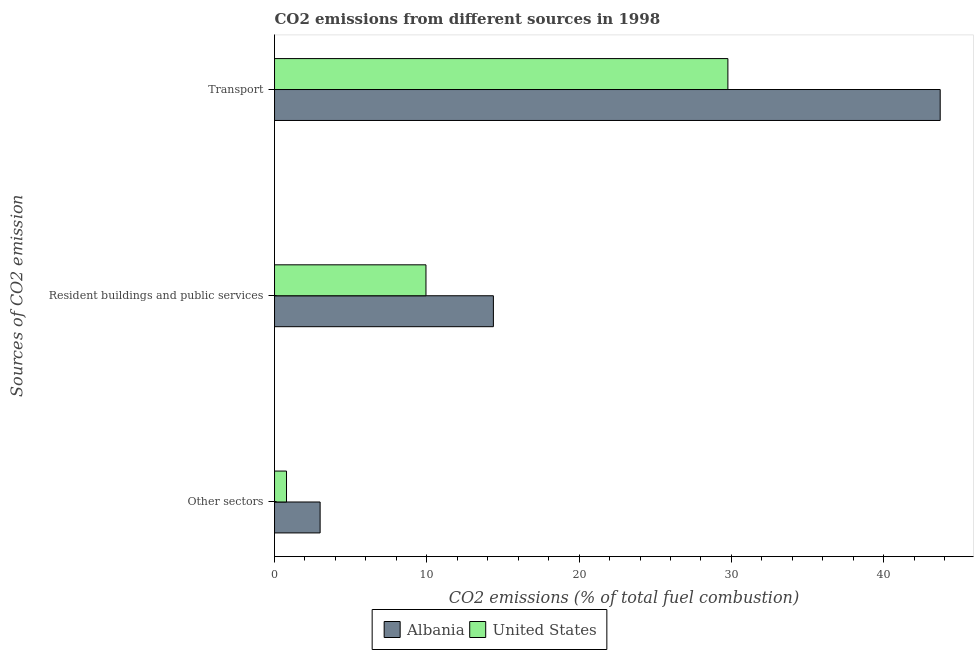How many different coloured bars are there?
Make the answer very short. 2. How many groups of bars are there?
Your response must be concise. 3. Are the number of bars per tick equal to the number of legend labels?
Offer a very short reply. Yes. Are the number of bars on each tick of the Y-axis equal?
Your answer should be compact. Yes. How many bars are there on the 1st tick from the bottom?
Make the answer very short. 2. What is the label of the 2nd group of bars from the top?
Provide a short and direct response. Resident buildings and public services. What is the percentage of co2 emissions from other sectors in Albania?
Provide a succinct answer. 2.99. Across all countries, what is the maximum percentage of co2 emissions from other sectors?
Ensure brevity in your answer.  2.99. Across all countries, what is the minimum percentage of co2 emissions from transport?
Offer a very short reply. 29.77. In which country was the percentage of co2 emissions from other sectors maximum?
Keep it short and to the point. Albania. What is the total percentage of co2 emissions from other sectors in the graph?
Give a very brief answer. 3.78. What is the difference between the percentage of co2 emissions from resident buildings and public services in United States and that in Albania?
Make the answer very short. -4.43. What is the difference between the percentage of co2 emissions from other sectors in United States and the percentage of co2 emissions from transport in Albania?
Your answer should be very brief. -42.93. What is the average percentage of co2 emissions from transport per country?
Your answer should be very brief. 36.74. What is the difference between the percentage of co2 emissions from resident buildings and public services and percentage of co2 emissions from other sectors in United States?
Your answer should be very brief. 9.16. What is the ratio of the percentage of co2 emissions from other sectors in United States to that in Albania?
Offer a very short reply. 0.26. Is the percentage of co2 emissions from other sectors in Albania less than that in United States?
Offer a terse response. No. What is the difference between the highest and the second highest percentage of co2 emissions from resident buildings and public services?
Offer a terse response. 4.43. What is the difference between the highest and the lowest percentage of co2 emissions from resident buildings and public services?
Provide a succinct answer. 4.43. In how many countries, is the percentage of co2 emissions from other sectors greater than the average percentage of co2 emissions from other sectors taken over all countries?
Your response must be concise. 1. Is it the case that in every country, the sum of the percentage of co2 emissions from other sectors and percentage of co2 emissions from resident buildings and public services is greater than the percentage of co2 emissions from transport?
Offer a very short reply. No. How many bars are there?
Keep it short and to the point. 6. How many countries are there in the graph?
Your answer should be compact. 2. What is the difference between two consecutive major ticks on the X-axis?
Ensure brevity in your answer.  10. Are the values on the major ticks of X-axis written in scientific E-notation?
Offer a very short reply. No. Does the graph contain grids?
Ensure brevity in your answer.  No. Where does the legend appear in the graph?
Offer a terse response. Bottom center. How many legend labels are there?
Offer a terse response. 2. How are the legend labels stacked?
Your answer should be compact. Horizontal. What is the title of the graph?
Your answer should be compact. CO2 emissions from different sources in 1998. What is the label or title of the X-axis?
Keep it short and to the point. CO2 emissions (% of total fuel combustion). What is the label or title of the Y-axis?
Keep it short and to the point. Sources of CO2 emission. What is the CO2 emissions (% of total fuel combustion) in Albania in Other sectors?
Make the answer very short. 2.99. What is the CO2 emissions (% of total fuel combustion) of United States in Other sectors?
Your response must be concise. 0.79. What is the CO2 emissions (% of total fuel combustion) of Albania in Resident buildings and public services?
Your answer should be compact. 14.37. What is the CO2 emissions (% of total fuel combustion) in United States in Resident buildings and public services?
Your answer should be very brief. 9.94. What is the CO2 emissions (% of total fuel combustion) in Albania in Transport?
Offer a terse response. 43.71. What is the CO2 emissions (% of total fuel combustion) of United States in Transport?
Offer a very short reply. 29.77. Across all Sources of CO2 emission, what is the maximum CO2 emissions (% of total fuel combustion) in Albania?
Give a very brief answer. 43.71. Across all Sources of CO2 emission, what is the maximum CO2 emissions (% of total fuel combustion) in United States?
Ensure brevity in your answer.  29.77. Across all Sources of CO2 emission, what is the minimum CO2 emissions (% of total fuel combustion) of Albania?
Offer a terse response. 2.99. Across all Sources of CO2 emission, what is the minimum CO2 emissions (% of total fuel combustion) of United States?
Your response must be concise. 0.79. What is the total CO2 emissions (% of total fuel combustion) in Albania in the graph?
Offer a terse response. 61.08. What is the total CO2 emissions (% of total fuel combustion) in United States in the graph?
Your answer should be very brief. 40.5. What is the difference between the CO2 emissions (% of total fuel combustion) of Albania in Other sectors and that in Resident buildings and public services?
Keep it short and to the point. -11.38. What is the difference between the CO2 emissions (% of total fuel combustion) in United States in Other sectors and that in Resident buildings and public services?
Give a very brief answer. -9.16. What is the difference between the CO2 emissions (% of total fuel combustion) in Albania in Other sectors and that in Transport?
Offer a very short reply. -40.72. What is the difference between the CO2 emissions (% of total fuel combustion) of United States in Other sectors and that in Transport?
Your answer should be very brief. -28.98. What is the difference between the CO2 emissions (% of total fuel combustion) in Albania in Resident buildings and public services and that in Transport?
Keep it short and to the point. -29.34. What is the difference between the CO2 emissions (% of total fuel combustion) in United States in Resident buildings and public services and that in Transport?
Give a very brief answer. -19.83. What is the difference between the CO2 emissions (% of total fuel combustion) in Albania in Other sectors and the CO2 emissions (% of total fuel combustion) in United States in Resident buildings and public services?
Your answer should be very brief. -6.95. What is the difference between the CO2 emissions (% of total fuel combustion) of Albania in Other sectors and the CO2 emissions (% of total fuel combustion) of United States in Transport?
Give a very brief answer. -26.78. What is the difference between the CO2 emissions (% of total fuel combustion) in Albania in Resident buildings and public services and the CO2 emissions (% of total fuel combustion) in United States in Transport?
Give a very brief answer. -15.4. What is the average CO2 emissions (% of total fuel combustion) in Albania per Sources of CO2 emission?
Give a very brief answer. 20.36. What is the average CO2 emissions (% of total fuel combustion) of United States per Sources of CO2 emission?
Offer a very short reply. 13.5. What is the difference between the CO2 emissions (% of total fuel combustion) of Albania and CO2 emissions (% of total fuel combustion) of United States in Other sectors?
Give a very brief answer. 2.21. What is the difference between the CO2 emissions (% of total fuel combustion) in Albania and CO2 emissions (% of total fuel combustion) in United States in Resident buildings and public services?
Offer a very short reply. 4.43. What is the difference between the CO2 emissions (% of total fuel combustion) in Albania and CO2 emissions (% of total fuel combustion) in United States in Transport?
Ensure brevity in your answer.  13.94. What is the ratio of the CO2 emissions (% of total fuel combustion) of Albania in Other sectors to that in Resident buildings and public services?
Give a very brief answer. 0.21. What is the ratio of the CO2 emissions (% of total fuel combustion) in United States in Other sectors to that in Resident buildings and public services?
Your answer should be compact. 0.08. What is the ratio of the CO2 emissions (% of total fuel combustion) in Albania in Other sectors to that in Transport?
Offer a terse response. 0.07. What is the ratio of the CO2 emissions (% of total fuel combustion) in United States in Other sectors to that in Transport?
Your response must be concise. 0.03. What is the ratio of the CO2 emissions (% of total fuel combustion) in Albania in Resident buildings and public services to that in Transport?
Your answer should be very brief. 0.33. What is the ratio of the CO2 emissions (% of total fuel combustion) of United States in Resident buildings and public services to that in Transport?
Your response must be concise. 0.33. What is the difference between the highest and the second highest CO2 emissions (% of total fuel combustion) of Albania?
Offer a terse response. 29.34. What is the difference between the highest and the second highest CO2 emissions (% of total fuel combustion) in United States?
Make the answer very short. 19.83. What is the difference between the highest and the lowest CO2 emissions (% of total fuel combustion) of Albania?
Make the answer very short. 40.72. What is the difference between the highest and the lowest CO2 emissions (% of total fuel combustion) in United States?
Provide a succinct answer. 28.98. 